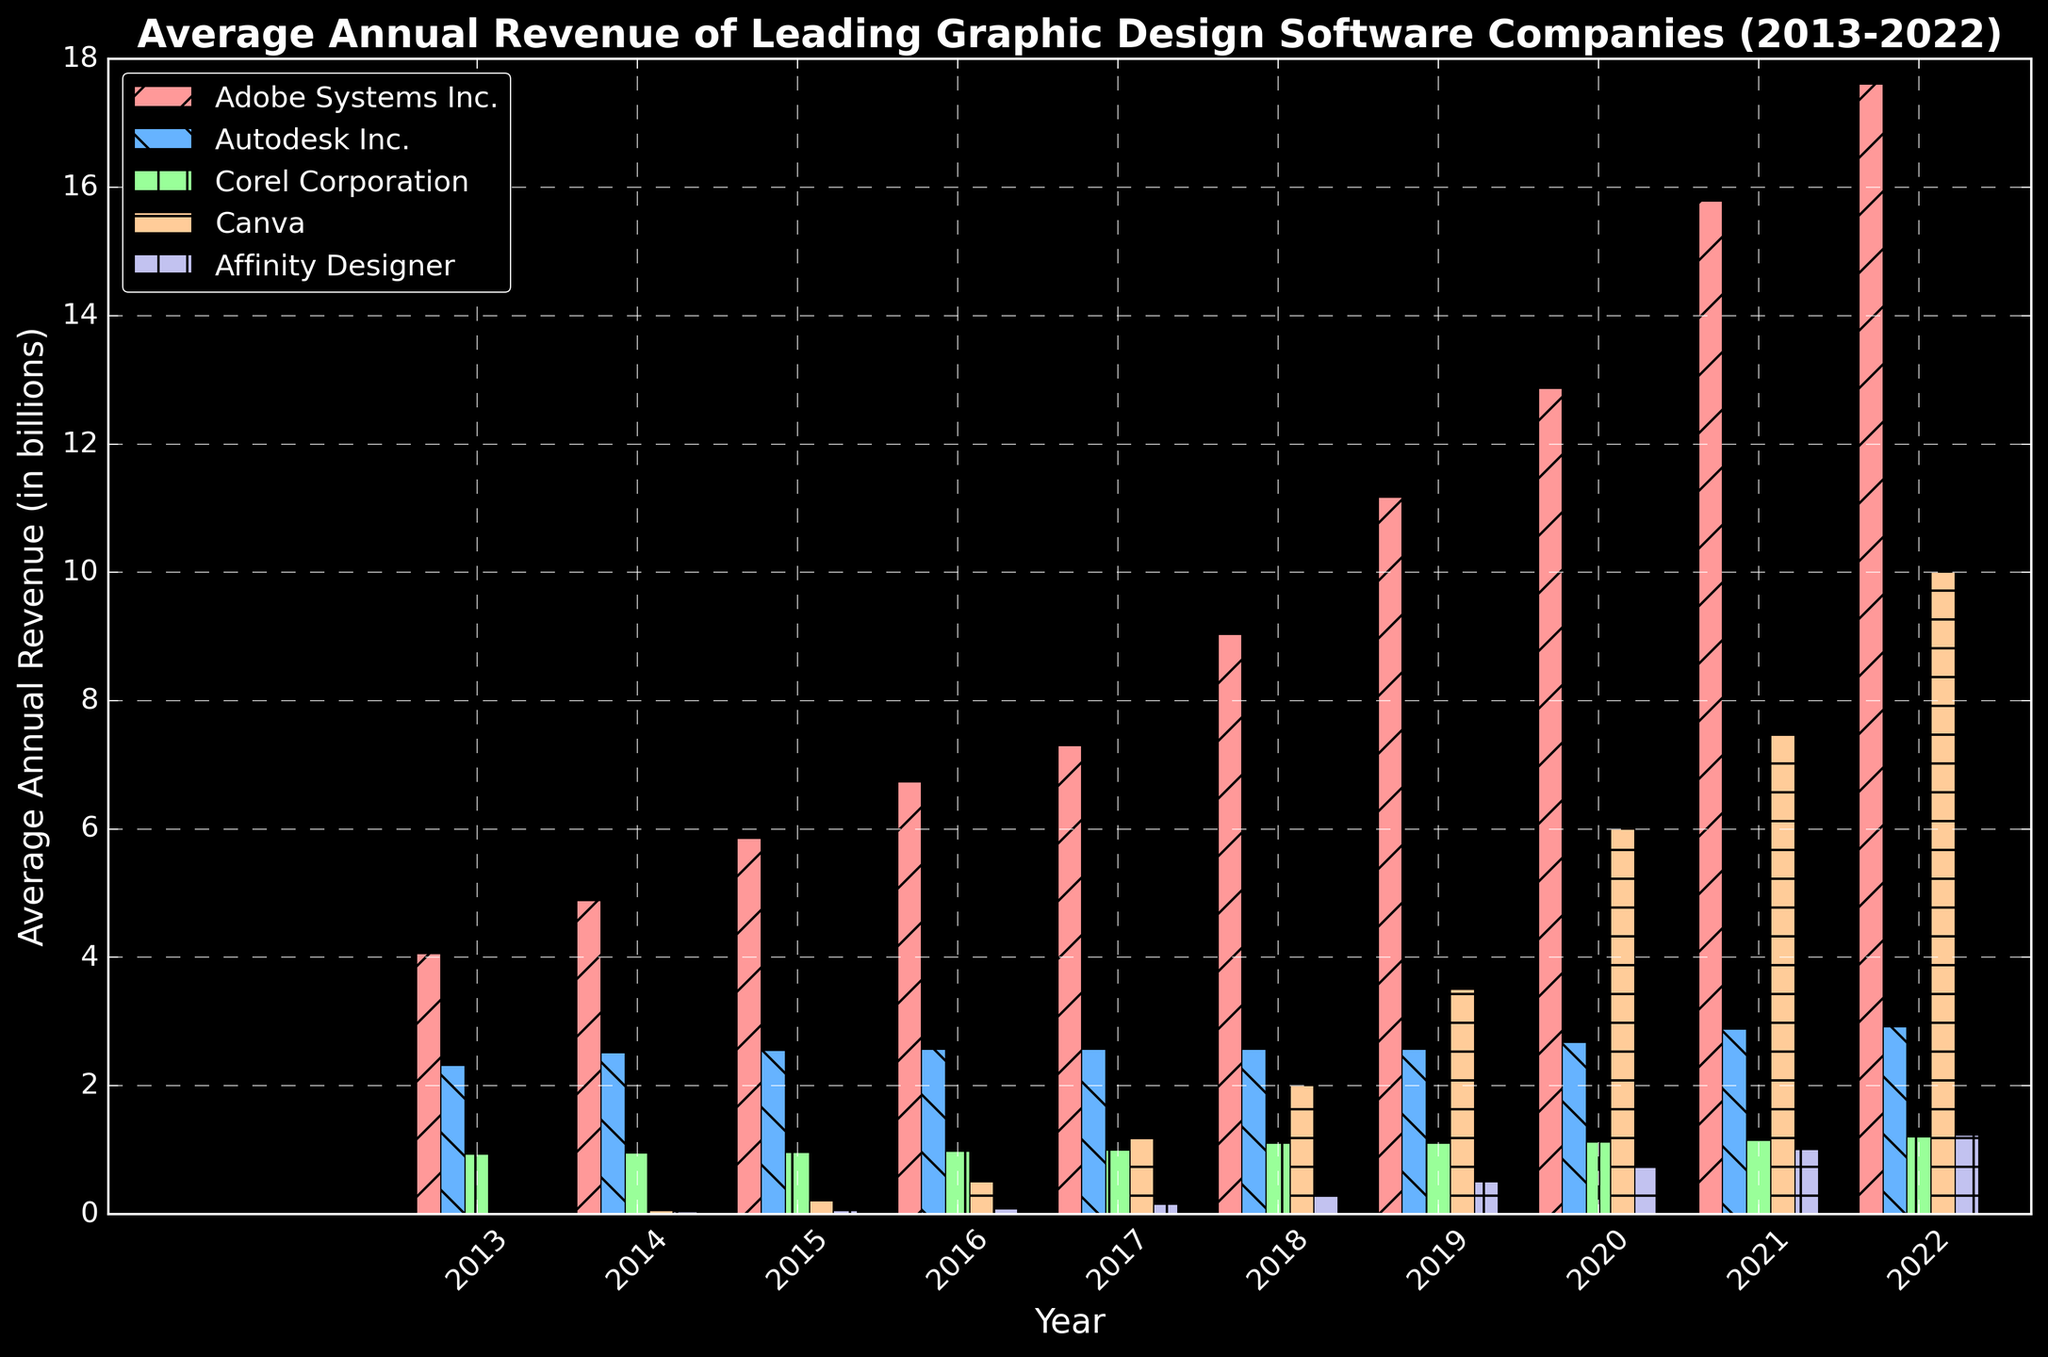what was the average revenue of all companies in 2017? Add up the revenues for all companies in 2017: 7.30 + 2.57 + 0.99 + 1.20 + 0.15 = 12.21 billion. Then divide by the number of companies: 12.21 / 5 = 2.442.
Answer: 2.442 billion Did Canva's revenue exceed Corel Corporation's revenue in 2020? Compare the bar heights of Canva and Corel Corporation in 2020. Canva's revenue is 6.00 billion whereas Corel Corporation's revenue is 1.12 billion for that year.
Answer: Yes Which company experienced the greatest increase in revenue from 2016 to 2017? Examine the bars of all companies in the years 2016 and 2017. Adobe Systems Inc. increased from 6.73 to 7.30 (0.57), Autodesk Inc. stayed the same at 2.57, Corel Corporation increased from 0.98 to 0.99 (0.01), Canva increased from 0.50 to 1.20 (0.70), and Affinity Designer increased from 0.08 to 0.15 (0.07).
Answer: Canva Which year showed the highest average annual revenue for Adobe Systems Inc.? Look at the tallest bar for Adobe Systems Inc. over the years. The highest is in 2022 with 17.61 billion.
Answer: 2022 Did Affinity Designer's revenue ever surpass Corel Corporation's revenue? Check the bars for Affinity Designer and Corel Corporation over all the years. Corel Corporation's revenues are always higher than Affinity Designer for the presented years.
Answer: No Which two companies had equal revenue in 2018? Examine the bars for 2018. Autodesk Inc. and Corel Corporation both had revenues of 2.57 billion.
Answer: Autodesk Inc. and Corel Corporation What was the total revenue for Canva over the entire decade? Add up Canva's annual revenues: 0.01 + 0.05 + 0.20 + 0.50 + 1.20 + 2.00 + 3.50 + 6.00 + 7.50 + 10.00 = 31.96 billion.
Answer: 31.96 billion Did any company besides Adobe Systems Inc. surpass 10 billion in revenue by 2022? Examine the bars for 2022. Canva also surpassed 10 billion in revenue with 10.00 billion.
Answer: Yes, Canva How much more revenue did Adobe Systems Inc. make in 2022 compared to 2013? Subtract the revenue of Adobe Systems Inc. in 2013 from that in 2022: 17.61 - 4.06 = 13.55 billion.
Answer: 13.55 billion Which company had the smallest growth in revenue between 2014 and 2022? Calculate the revenue difference for each company between 2014 and 2022: 
Adobe Systems Inc.: 17.61 - 4.88 = 12.73
Autodesk Inc.: 2.92 - 2.51 = 0.41
Corel Corporation: 1.20 - 0.95 = 0.25
Canva: 10.00 - 0.05 = 9.95
Affinity Designer: 1.23 - 0.03 = 1.20
Corel Corporation had the smallest growth.
Answer: Corel Corporation 